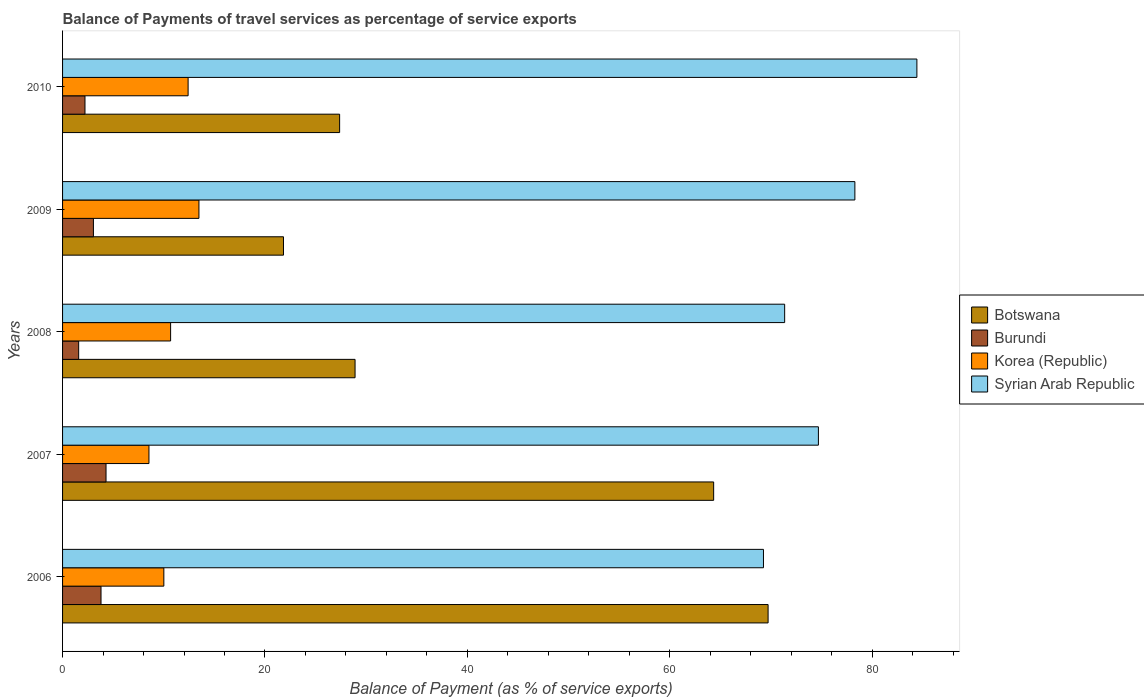How many different coloured bars are there?
Make the answer very short. 4. How many bars are there on the 3rd tick from the top?
Give a very brief answer. 4. What is the label of the 3rd group of bars from the top?
Keep it short and to the point. 2008. What is the balance of payments of travel services in Syrian Arab Republic in 2006?
Provide a succinct answer. 69.25. Across all years, what is the maximum balance of payments of travel services in Burundi?
Your answer should be compact. 4.29. Across all years, what is the minimum balance of payments of travel services in Burundi?
Keep it short and to the point. 1.59. In which year was the balance of payments of travel services in Botswana maximum?
Your answer should be compact. 2006. What is the total balance of payments of travel services in Syrian Arab Republic in the graph?
Offer a terse response. 377.99. What is the difference between the balance of payments of travel services in Botswana in 2006 and that in 2010?
Provide a short and direct response. 42.34. What is the difference between the balance of payments of travel services in Syrian Arab Republic in 2010 and the balance of payments of travel services in Korea (Republic) in 2006?
Your answer should be very brief. 74.41. What is the average balance of payments of travel services in Syrian Arab Republic per year?
Provide a succinct answer. 75.6. In the year 2006, what is the difference between the balance of payments of travel services in Syrian Arab Republic and balance of payments of travel services in Korea (Republic)?
Give a very brief answer. 59.25. What is the ratio of the balance of payments of travel services in Botswana in 2007 to that in 2008?
Give a very brief answer. 2.23. Is the difference between the balance of payments of travel services in Syrian Arab Republic in 2006 and 2010 greater than the difference between the balance of payments of travel services in Korea (Republic) in 2006 and 2010?
Offer a terse response. No. What is the difference between the highest and the second highest balance of payments of travel services in Syrian Arab Republic?
Keep it short and to the point. 6.13. What is the difference between the highest and the lowest balance of payments of travel services in Syrian Arab Republic?
Your response must be concise. 15.16. What does the 1st bar from the top in 2010 represents?
Make the answer very short. Syrian Arab Republic. What does the 1st bar from the bottom in 2006 represents?
Your answer should be compact. Botswana. Is it the case that in every year, the sum of the balance of payments of travel services in Botswana and balance of payments of travel services in Korea (Republic) is greater than the balance of payments of travel services in Syrian Arab Republic?
Your response must be concise. No. How many bars are there?
Provide a succinct answer. 20. Are all the bars in the graph horizontal?
Offer a terse response. Yes. What is the difference between two consecutive major ticks on the X-axis?
Give a very brief answer. 20. Does the graph contain any zero values?
Give a very brief answer. No. Does the graph contain grids?
Keep it short and to the point. No. What is the title of the graph?
Ensure brevity in your answer.  Balance of Payments of travel services as percentage of service exports. Does "Angola" appear as one of the legend labels in the graph?
Provide a succinct answer. No. What is the label or title of the X-axis?
Your response must be concise. Balance of Payment (as % of service exports). What is the label or title of the Y-axis?
Your answer should be compact. Years. What is the Balance of Payment (as % of service exports) of Botswana in 2006?
Ensure brevity in your answer.  69.71. What is the Balance of Payment (as % of service exports) of Burundi in 2006?
Your answer should be compact. 3.8. What is the Balance of Payment (as % of service exports) in Korea (Republic) in 2006?
Provide a short and direct response. 10.01. What is the Balance of Payment (as % of service exports) of Syrian Arab Republic in 2006?
Your answer should be very brief. 69.25. What is the Balance of Payment (as % of service exports) in Botswana in 2007?
Offer a very short reply. 64.33. What is the Balance of Payment (as % of service exports) of Burundi in 2007?
Provide a succinct answer. 4.29. What is the Balance of Payment (as % of service exports) of Korea (Republic) in 2007?
Your answer should be very brief. 8.54. What is the Balance of Payment (as % of service exports) of Syrian Arab Republic in 2007?
Keep it short and to the point. 74.68. What is the Balance of Payment (as % of service exports) of Botswana in 2008?
Make the answer very short. 28.9. What is the Balance of Payment (as % of service exports) in Burundi in 2008?
Provide a short and direct response. 1.59. What is the Balance of Payment (as % of service exports) in Korea (Republic) in 2008?
Make the answer very short. 10.68. What is the Balance of Payment (as % of service exports) in Syrian Arab Republic in 2008?
Provide a succinct answer. 71.35. What is the Balance of Payment (as % of service exports) in Botswana in 2009?
Offer a very short reply. 21.83. What is the Balance of Payment (as % of service exports) of Burundi in 2009?
Offer a very short reply. 3.05. What is the Balance of Payment (as % of service exports) of Korea (Republic) in 2009?
Keep it short and to the point. 13.48. What is the Balance of Payment (as % of service exports) in Syrian Arab Republic in 2009?
Ensure brevity in your answer.  78.29. What is the Balance of Payment (as % of service exports) in Botswana in 2010?
Provide a succinct answer. 27.38. What is the Balance of Payment (as % of service exports) of Burundi in 2010?
Keep it short and to the point. 2.21. What is the Balance of Payment (as % of service exports) in Korea (Republic) in 2010?
Provide a short and direct response. 12.4. What is the Balance of Payment (as % of service exports) of Syrian Arab Republic in 2010?
Make the answer very short. 84.41. Across all years, what is the maximum Balance of Payment (as % of service exports) of Botswana?
Make the answer very short. 69.71. Across all years, what is the maximum Balance of Payment (as % of service exports) of Burundi?
Make the answer very short. 4.29. Across all years, what is the maximum Balance of Payment (as % of service exports) of Korea (Republic)?
Keep it short and to the point. 13.48. Across all years, what is the maximum Balance of Payment (as % of service exports) in Syrian Arab Republic?
Offer a terse response. 84.41. Across all years, what is the minimum Balance of Payment (as % of service exports) in Botswana?
Give a very brief answer. 21.83. Across all years, what is the minimum Balance of Payment (as % of service exports) of Burundi?
Provide a short and direct response. 1.59. Across all years, what is the minimum Balance of Payment (as % of service exports) in Korea (Republic)?
Provide a succinct answer. 8.54. Across all years, what is the minimum Balance of Payment (as % of service exports) in Syrian Arab Republic?
Provide a succinct answer. 69.25. What is the total Balance of Payment (as % of service exports) of Botswana in the graph?
Offer a very short reply. 212.15. What is the total Balance of Payment (as % of service exports) in Burundi in the graph?
Your answer should be very brief. 14.95. What is the total Balance of Payment (as % of service exports) of Korea (Republic) in the graph?
Make the answer very short. 55.1. What is the total Balance of Payment (as % of service exports) in Syrian Arab Republic in the graph?
Give a very brief answer. 377.99. What is the difference between the Balance of Payment (as % of service exports) in Botswana in 2006 and that in 2007?
Your answer should be compact. 5.38. What is the difference between the Balance of Payment (as % of service exports) of Burundi in 2006 and that in 2007?
Provide a short and direct response. -0.49. What is the difference between the Balance of Payment (as % of service exports) in Korea (Republic) in 2006 and that in 2007?
Offer a terse response. 1.47. What is the difference between the Balance of Payment (as % of service exports) of Syrian Arab Republic in 2006 and that in 2007?
Your answer should be very brief. -5.43. What is the difference between the Balance of Payment (as % of service exports) in Botswana in 2006 and that in 2008?
Offer a very short reply. 40.81. What is the difference between the Balance of Payment (as % of service exports) of Burundi in 2006 and that in 2008?
Make the answer very short. 2.21. What is the difference between the Balance of Payment (as % of service exports) in Korea (Republic) in 2006 and that in 2008?
Offer a very short reply. -0.67. What is the difference between the Balance of Payment (as % of service exports) of Syrian Arab Republic in 2006 and that in 2008?
Provide a succinct answer. -2.09. What is the difference between the Balance of Payment (as % of service exports) in Botswana in 2006 and that in 2009?
Your answer should be very brief. 47.88. What is the difference between the Balance of Payment (as % of service exports) in Burundi in 2006 and that in 2009?
Provide a succinct answer. 0.75. What is the difference between the Balance of Payment (as % of service exports) in Korea (Republic) in 2006 and that in 2009?
Ensure brevity in your answer.  -3.47. What is the difference between the Balance of Payment (as % of service exports) in Syrian Arab Republic in 2006 and that in 2009?
Make the answer very short. -9.03. What is the difference between the Balance of Payment (as % of service exports) of Botswana in 2006 and that in 2010?
Ensure brevity in your answer.  42.34. What is the difference between the Balance of Payment (as % of service exports) of Burundi in 2006 and that in 2010?
Provide a short and direct response. 1.59. What is the difference between the Balance of Payment (as % of service exports) in Korea (Republic) in 2006 and that in 2010?
Ensure brevity in your answer.  -2.4. What is the difference between the Balance of Payment (as % of service exports) of Syrian Arab Republic in 2006 and that in 2010?
Provide a succinct answer. -15.16. What is the difference between the Balance of Payment (as % of service exports) of Botswana in 2007 and that in 2008?
Make the answer very short. 35.43. What is the difference between the Balance of Payment (as % of service exports) in Burundi in 2007 and that in 2008?
Your answer should be compact. 2.7. What is the difference between the Balance of Payment (as % of service exports) of Korea (Republic) in 2007 and that in 2008?
Give a very brief answer. -2.14. What is the difference between the Balance of Payment (as % of service exports) of Syrian Arab Republic in 2007 and that in 2008?
Ensure brevity in your answer.  3.33. What is the difference between the Balance of Payment (as % of service exports) in Botswana in 2007 and that in 2009?
Ensure brevity in your answer.  42.5. What is the difference between the Balance of Payment (as % of service exports) in Burundi in 2007 and that in 2009?
Make the answer very short. 1.25. What is the difference between the Balance of Payment (as % of service exports) in Korea (Republic) in 2007 and that in 2009?
Provide a succinct answer. -4.94. What is the difference between the Balance of Payment (as % of service exports) in Syrian Arab Republic in 2007 and that in 2009?
Your response must be concise. -3.6. What is the difference between the Balance of Payment (as % of service exports) in Botswana in 2007 and that in 2010?
Your answer should be very brief. 36.96. What is the difference between the Balance of Payment (as % of service exports) of Burundi in 2007 and that in 2010?
Ensure brevity in your answer.  2.08. What is the difference between the Balance of Payment (as % of service exports) in Korea (Republic) in 2007 and that in 2010?
Give a very brief answer. -3.87. What is the difference between the Balance of Payment (as % of service exports) of Syrian Arab Republic in 2007 and that in 2010?
Provide a short and direct response. -9.73. What is the difference between the Balance of Payment (as % of service exports) of Botswana in 2008 and that in 2009?
Ensure brevity in your answer.  7.07. What is the difference between the Balance of Payment (as % of service exports) of Burundi in 2008 and that in 2009?
Provide a succinct answer. -1.46. What is the difference between the Balance of Payment (as % of service exports) in Korea (Republic) in 2008 and that in 2009?
Your answer should be very brief. -2.8. What is the difference between the Balance of Payment (as % of service exports) in Syrian Arab Republic in 2008 and that in 2009?
Make the answer very short. -6.94. What is the difference between the Balance of Payment (as % of service exports) of Botswana in 2008 and that in 2010?
Offer a very short reply. 1.53. What is the difference between the Balance of Payment (as % of service exports) in Burundi in 2008 and that in 2010?
Provide a succinct answer. -0.62. What is the difference between the Balance of Payment (as % of service exports) of Korea (Republic) in 2008 and that in 2010?
Your answer should be very brief. -1.73. What is the difference between the Balance of Payment (as % of service exports) in Syrian Arab Republic in 2008 and that in 2010?
Provide a succinct answer. -13.07. What is the difference between the Balance of Payment (as % of service exports) of Botswana in 2009 and that in 2010?
Your response must be concise. -5.55. What is the difference between the Balance of Payment (as % of service exports) of Burundi in 2009 and that in 2010?
Your answer should be compact. 0.83. What is the difference between the Balance of Payment (as % of service exports) of Korea (Republic) in 2009 and that in 2010?
Give a very brief answer. 1.07. What is the difference between the Balance of Payment (as % of service exports) of Syrian Arab Republic in 2009 and that in 2010?
Your answer should be very brief. -6.13. What is the difference between the Balance of Payment (as % of service exports) in Botswana in 2006 and the Balance of Payment (as % of service exports) in Burundi in 2007?
Provide a succinct answer. 65.42. What is the difference between the Balance of Payment (as % of service exports) of Botswana in 2006 and the Balance of Payment (as % of service exports) of Korea (Republic) in 2007?
Your response must be concise. 61.18. What is the difference between the Balance of Payment (as % of service exports) of Botswana in 2006 and the Balance of Payment (as % of service exports) of Syrian Arab Republic in 2007?
Keep it short and to the point. -4.97. What is the difference between the Balance of Payment (as % of service exports) of Burundi in 2006 and the Balance of Payment (as % of service exports) of Korea (Republic) in 2007?
Ensure brevity in your answer.  -4.74. What is the difference between the Balance of Payment (as % of service exports) of Burundi in 2006 and the Balance of Payment (as % of service exports) of Syrian Arab Republic in 2007?
Ensure brevity in your answer.  -70.88. What is the difference between the Balance of Payment (as % of service exports) of Korea (Republic) in 2006 and the Balance of Payment (as % of service exports) of Syrian Arab Republic in 2007?
Provide a succinct answer. -64.68. What is the difference between the Balance of Payment (as % of service exports) in Botswana in 2006 and the Balance of Payment (as % of service exports) in Burundi in 2008?
Give a very brief answer. 68.12. What is the difference between the Balance of Payment (as % of service exports) in Botswana in 2006 and the Balance of Payment (as % of service exports) in Korea (Republic) in 2008?
Offer a very short reply. 59.04. What is the difference between the Balance of Payment (as % of service exports) in Botswana in 2006 and the Balance of Payment (as % of service exports) in Syrian Arab Republic in 2008?
Make the answer very short. -1.64. What is the difference between the Balance of Payment (as % of service exports) of Burundi in 2006 and the Balance of Payment (as % of service exports) of Korea (Republic) in 2008?
Your answer should be very brief. -6.88. What is the difference between the Balance of Payment (as % of service exports) in Burundi in 2006 and the Balance of Payment (as % of service exports) in Syrian Arab Republic in 2008?
Provide a succinct answer. -67.55. What is the difference between the Balance of Payment (as % of service exports) in Korea (Republic) in 2006 and the Balance of Payment (as % of service exports) in Syrian Arab Republic in 2008?
Your answer should be very brief. -61.34. What is the difference between the Balance of Payment (as % of service exports) of Botswana in 2006 and the Balance of Payment (as % of service exports) of Burundi in 2009?
Give a very brief answer. 66.66. What is the difference between the Balance of Payment (as % of service exports) in Botswana in 2006 and the Balance of Payment (as % of service exports) in Korea (Republic) in 2009?
Offer a terse response. 56.24. What is the difference between the Balance of Payment (as % of service exports) of Botswana in 2006 and the Balance of Payment (as % of service exports) of Syrian Arab Republic in 2009?
Your answer should be very brief. -8.57. What is the difference between the Balance of Payment (as % of service exports) in Burundi in 2006 and the Balance of Payment (as % of service exports) in Korea (Republic) in 2009?
Provide a short and direct response. -9.68. What is the difference between the Balance of Payment (as % of service exports) of Burundi in 2006 and the Balance of Payment (as % of service exports) of Syrian Arab Republic in 2009?
Make the answer very short. -74.49. What is the difference between the Balance of Payment (as % of service exports) of Korea (Republic) in 2006 and the Balance of Payment (as % of service exports) of Syrian Arab Republic in 2009?
Ensure brevity in your answer.  -68.28. What is the difference between the Balance of Payment (as % of service exports) in Botswana in 2006 and the Balance of Payment (as % of service exports) in Burundi in 2010?
Offer a terse response. 67.5. What is the difference between the Balance of Payment (as % of service exports) of Botswana in 2006 and the Balance of Payment (as % of service exports) of Korea (Republic) in 2010?
Make the answer very short. 57.31. What is the difference between the Balance of Payment (as % of service exports) of Botswana in 2006 and the Balance of Payment (as % of service exports) of Syrian Arab Republic in 2010?
Make the answer very short. -14.7. What is the difference between the Balance of Payment (as % of service exports) in Burundi in 2006 and the Balance of Payment (as % of service exports) in Korea (Republic) in 2010?
Make the answer very short. -8.6. What is the difference between the Balance of Payment (as % of service exports) of Burundi in 2006 and the Balance of Payment (as % of service exports) of Syrian Arab Republic in 2010?
Ensure brevity in your answer.  -80.61. What is the difference between the Balance of Payment (as % of service exports) in Korea (Republic) in 2006 and the Balance of Payment (as % of service exports) in Syrian Arab Republic in 2010?
Provide a short and direct response. -74.41. What is the difference between the Balance of Payment (as % of service exports) of Botswana in 2007 and the Balance of Payment (as % of service exports) of Burundi in 2008?
Your response must be concise. 62.74. What is the difference between the Balance of Payment (as % of service exports) in Botswana in 2007 and the Balance of Payment (as % of service exports) in Korea (Republic) in 2008?
Offer a terse response. 53.66. What is the difference between the Balance of Payment (as % of service exports) in Botswana in 2007 and the Balance of Payment (as % of service exports) in Syrian Arab Republic in 2008?
Keep it short and to the point. -7.01. What is the difference between the Balance of Payment (as % of service exports) of Burundi in 2007 and the Balance of Payment (as % of service exports) of Korea (Republic) in 2008?
Provide a short and direct response. -6.38. What is the difference between the Balance of Payment (as % of service exports) of Burundi in 2007 and the Balance of Payment (as % of service exports) of Syrian Arab Republic in 2008?
Provide a short and direct response. -67.05. What is the difference between the Balance of Payment (as % of service exports) in Korea (Republic) in 2007 and the Balance of Payment (as % of service exports) in Syrian Arab Republic in 2008?
Make the answer very short. -62.81. What is the difference between the Balance of Payment (as % of service exports) of Botswana in 2007 and the Balance of Payment (as % of service exports) of Burundi in 2009?
Your answer should be compact. 61.28. What is the difference between the Balance of Payment (as % of service exports) of Botswana in 2007 and the Balance of Payment (as % of service exports) of Korea (Republic) in 2009?
Keep it short and to the point. 50.86. What is the difference between the Balance of Payment (as % of service exports) of Botswana in 2007 and the Balance of Payment (as % of service exports) of Syrian Arab Republic in 2009?
Provide a short and direct response. -13.95. What is the difference between the Balance of Payment (as % of service exports) of Burundi in 2007 and the Balance of Payment (as % of service exports) of Korea (Republic) in 2009?
Ensure brevity in your answer.  -9.18. What is the difference between the Balance of Payment (as % of service exports) of Burundi in 2007 and the Balance of Payment (as % of service exports) of Syrian Arab Republic in 2009?
Provide a succinct answer. -73.99. What is the difference between the Balance of Payment (as % of service exports) of Korea (Republic) in 2007 and the Balance of Payment (as % of service exports) of Syrian Arab Republic in 2009?
Your answer should be compact. -69.75. What is the difference between the Balance of Payment (as % of service exports) of Botswana in 2007 and the Balance of Payment (as % of service exports) of Burundi in 2010?
Offer a terse response. 62.12. What is the difference between the Balance of Payment (as % of service exports) in Botswana in 2007 and the Balance of Payment (as % of service exports) in Korea (Republic) in 2010?
Offer a terse response. 51.93. What is the difference between the Balance of Payment (as % of service exports) in Botswana in 2007 and the Balance of Payment (as % of service exports) in Syrian Arab Republic in 2010?
Your response must be concise. -20.08. What is the difference between the Balance of Payment (as % of service exports) of Burundi in 2007 and the Balance of Payment (as % of service exports) of Korea (Republic) in 2010?
Your response must be concise. -8.11. What is the difference between the Balance of Payment (as % of service exports) of Burundi in 2007 and the Balance of Payment (as % of service exports) of Syrian Arab Republic in 2010?
Ensure brevity in your answer.  -80.12. What is the difference between the Balance of Payment (as % of service exports) in Korea (Republic) in 2007 and the Balance of Payment (as % of service exports) in Syrian Arab Republic in 2010?
Keep it short and to the point. -75.88. What is the difference between the Balance of Payment (as % of service exports) of Botswana in 2008 and the Balance of Payment (as % of service exports) of Burundi in 2009?
Give a very brief answer. 25.85. What is the difference between the Balance of Payment (as % of service exports) in Botswana in 2008 and the Balance of Payment (as % of service exports) in Korea (Republic) in 2009?
Provide a short and direct response. 15.43. What is the difference between the Balance of Payment (as % of service exports) in Botswana in 2008 and the Balance of Payment (as % of service exports) in Syrian Arab Republic in 2009?
Provide a short and direct response. -49.39. What is the difference between the Balance of Payment (as % of service exports) in Burundi in 2008 and the Balance of Payment (as % of service exports) in Korea (Republic) in 2009?
Keep it short and to the point. -11.88. What is the difference between the Balance of Payment (as % of service exports) of Burundi in 2008 and the Balance of Payment (as % of service exports) of Syrian Arab Republic in 2009?
Make the answer very short. -76.7. What is the difference between the Balance of Payment (as % of service exports) of Korea (Republic) in 2008 and the Balance of Payment (as % of service exports) of Syrian Arab Republic in 2009?
Provide a succinct answer. -67.61. What is the difference between the Balance of Payment (as % of service exports) in Botswana in 2008 and the Balance of Payment (as % of service exports) in Burundi in 2010?
Ensure brevity in your answer.  26.69. What is the difference between the Balance of Payment (as % of service exports) of Botswana in 2008 and the Balance of Payment (as % of service exports) of Korea (Republic) in 2010?
Offer a very short reply. 16.5. What is the difference between the Balance of Payment (as % of service exports) in Botswana in 2008 and the Balance of Payment (as % of service exports) in Syrian Arab Republic in 2010?
Your response must be concise. -55.51. What is the difference between the Balance of Payment (as % of service exports) in Burundi in 2008 and the Balance of Payment (as % of service exports) in Korea (Republic) in 2010?
Provide a short and direct response. -10.81. What is the difference between the Balance of Payment (as % of service exports) in Burundi in 2008 and the Balance of Payment (as % of service exports) in Syrian Arab Republic in 2010?
Give a very brief answer. -82.82. What is the difference between the Balance of Payment (as % of service exports) in Korea (Republic) in 2008 and the Balance of Payment (as % of service exports) in Syrian Arab Republic in 2010?
Make the answer very short. -73.74. What is the difference between the Balance of Payment (as % of service exports) in Botswana in 2009 and the Balance of Payment (as % of service exports) in Burundi in 2010?
Give a very brief answer. 19.61. What is the difference between the Balance of Payment (as % of service exports) of Botswana in 2009 and the Balance of Payment (as % of service exports) of Korea (Republic) in 2010?
Give a very brief answer. 9.42. What is the difference between the Balance of Payment (as % of service exports) in Botswana in 2009 and the Balance of Payment (as % of service exports) in Syrian Arab Republic in 2010?
Ensure brevity in your answer.  -62.58. What is the difference between the Balance of Payment (as % of service exports) in Burundi in 2009 and the Balance of Payment (as % of service exports) in Korea (Republic) in 2010?
Your answer should be very brief. -9.36. What is the difference between the Balance of Payment (as % of service exports) of Burundi in 2009 and the Balance of Payment (as % of service exports) of Syrian Arab Republic in 2010?
Give a very brief answer. -81.36. What is the difference between the Balance of Payment (as % of service exports) of Korea (Republic) in 2009 and the Balance of Payment (as % of service exports) of Syrian Arab Republic in 2010?
Keep it short and to the point. -70.94. What is the average Balance of Payment (as % of service exports) of Botswana per year?
Offer a terse response. 42.43. What is the average Balance of Payment (as % of service exports) in Burundi per year?
Keep it short and to the point. 2.99. What is the average Balance of Payment (as % of service exports) of Korea (Republic) per year?
Your answer should be very brief. 11.02. What is the average Balance of Payment (as % of service exports) of Syrian Arab Republic per year?
Offer a terse response. 75.6. In the year 2006, what is the difference between the Balance of Payment (as % of service exports) in Botswana and Balance of Payment (as % of service exports) in Burundi?
Offer a very short reply. 65.91. In the year 2006, what is the difference between the Balance of Payment (as % of service exports) in Botswana and Balance of Payment (as % of service exports) in Korea (Republic)?
Provide a succinct answer. 59.71. In the year 2006, what is the difference between the Balance of Payment (as % of service exports) of Botswana and Balance of Payment (as % of service exports) of Syrian Arab Republic?
Make the answer very short. 0.46. In the year 2006, what is the difference between the Balance of Payment (as % of service exports) of Burundi and Balance of Payment (as % of service exports) of Korea (Republic)?
Ensure brevity in your answer.  -6.21. In the year 2006, what is the difference between the Balance of Payment (as % of service exports) of Burundi and Balance of Payment (as % of service exports) of Syrian Arab Republic?
Give a very brief answer. -65.45. In the year 2006, what is the difference between the Balance of Payment (as % of service exports) of Korea (Republic) and Balance of Payment (as % of service exports) of Syrian Arab Republic?
Provide a short and direct response. -59.25. In the year 2007, what is the difference between the Balance of Payment (as % of service exports) in Botswana and Balance of Payment (as % of service exports) in Burundi?
Make the answer very short. 60.04. In the year 2007, what is the difference between the Balance of Payment (as % of service exports) in Botswana and Balance of Payment (as % of service exports) in Korea (Republic)?
Your response must be concise. 55.8. In the year 2007, what is the difference between the Balance of Payment (as % of service exports) in Botswana and Balance of Payment (as % of service exports) in Syrian Arab Republic?
Provide a short and direct response. -10.35. In the year 2007, what is the difference between the Balance of Payment (as % of service exports) in Burundi and Balance of Payment (as % of service exports) in Korea (Republic)?
Offer a terse response. -4.24. In the year 2007, what is the difference between the Balance of Payment (as % of service exports) in Burundi and Balance of Payment (as % of service exports) in Syrian Arab Republic?
Give a very brief answer. -70.39. In the year 2007, what is the difference between the Balance of Payment (as % of service exports) in Korea (Republic) and Balance of Payment (as % of service exports) in Syrian Arab Republic?
Your answer should be compact. -66.15. In the year 2008, what is the difference between the Balance of Payment (as % of service exports) of Botswana and Balance of Payment (as % of service exports) of Burundi?
Ensure brevity in your answer.  27.31. In the year 2008, what is the difference between the Balance of Payment (as % of service exports) in Botswana and Balance of Payment (as % of service exports) in Korea (Republic)?
Give a very brief answer. 18.23. In the year 2008, what is the difference between the Balance of Payment (as % of service exports) in Botswana and Balance of Payment (as % of service exports) in Syrian Arab Republic?
Give a very brief answer. -42.45. In the year 2008, what is the difference between the Balance of Payment (as % of service exports) in Burundi and Balance of Payment (as % of service exports) in Korea (Republic)?
Offer a very short reply. -9.08. In the year 2008, what is the difference between the Balance of Payment (as % of service exports) of Burundi and Balance of Payment (as % of service exports) of Syrian Arab Republic?
Make the answer very short. -69.76. In the year 2008, what is the difference between the Balance of Payment (as % of service exports) of Korea (Republic) and Balance of Payment (as % of service exports) of Syrian Arab Republic?
Your answer should be very brief. -60.67. In the year 2009, what is the difference between the Balance of Payment (as % of service exports) of Botswana and Balance of Payment (as % of service exports) of Burundi?
Your answer should be compact. 18.78. In the year 2009, what is the difference between the Balance of Payment (as % of service exports) in Botswana and Balance of Payment (as % of service exports) in Korea (Republic)?
Make the answer very short. 8.35. In the year 2009, what is the difference between the Balance of Payment (as % of service exports) of Botswana and Balance of Payment (as % of service exports) of Syrian Arab Republic?
Give a very brief answer. -56.46. In the year 2009, what is the difference between the Balance of Payment (as % of service exports) in Burundi and Balance of Payment (as % of service exports) in Korea (Republic)?
Your answer should be very brief. -10.43. In the year 2009, what is the difference between the Balance of Payment (as % of service exports) of Burundi and Balance of Payment (as % of service exports) of Syrian Arab Republic?
Your answer should be compact. -75.24. In the year 2009, what is the difference between the Balance of Payment (as % of service exports) of Korea (Republic) and Balance of Payment (as % of service exports) of Syrian Arab Republic?
Your answer should be compact. -64.81. In the year 2010, what is the difference between the Balance of Payment (as % of service exports) of Botswana and Balance of Payment (as % of service exports) of Burundi?
Provide a short and direct response. 25.16. In the year 2010, what is the difference between the Balance of Payment (as % of service exports) of Botswana and Balance of Payment (as % of service exports) of Korea (Republic)?
Offer a terse response. 14.97. In the year 2010, what is the difference between the Balance of Payment (as % of service exports) of Botswana and Balance of Payment (as % of service exports) of Syrian Arab Republic?
Your answer should be very brief. -57.04. In the year 2010, what is the difference between the Balance of Payment (as % of service exports) of Burundi and Balance of Payment (as % of service exports) of Korea (Republic)?
Your response must be concise. -10.19. In the year 2010, what is the difference between the Balance of Payment (as % of service exports) of Burundi and Balance of Payment (as % of service exports) of Syrian Arab Republic?
Your answer should be compact. -82.2. In the year 2010, what is the difference between the Balance of Payment (as % of service exports) of Korea (Republic) and Balance of Payment (as % of service exports) of Syrian Arab Republic?
Your response must be concise. -72.01. What is the ratio of the Balance of Payment (as % of service exports) in Botswana in 2006 to that in 2007?
Make the answer very short. 1.08. What is the ratio of the Balance of Payment (as % of service exports) in Burundi in 2006 to that in 2007?
Provide a short and direct response. 0.88. What is the ratio of the Balance of Payment (as % of service exports) of Korea (Republic) in 2006 to that in 2007?
Make the answer very short. 1.17. What is the ratio of the Balance of Payment (as % of service exports) of Syrian Arab Republic in 2006 to that in 2007?
Ensure brevity in your answer.  0.93. What is the ratio of the Balance of Payment (as % of service exports) of Botswana in 2006 to that in 2008?
Keep it short and to the point. 2.41. What is the ratio of the Balance of Payment (as % of service exports) in Burundi in 2006 to that in 2008?
Provide a short and direct response. 2.39. What is the ratio of the Balance of Payment (as % of service exports) in Korea (Republic) in 2006 to that in 2008?
Provide a short and direct response. 0.94. What is the ratio of the Balance of Payment (as % of service exports) of Syrian Arab Republic in 2006 to that in 2008?
Provide a short and direct response. 0.97. What is the ratio of the Balance of Payment (as % of service exports) in Botswana in 2006 to that in 2009?
Your response must be concise. 3.19. What is the ratio of the Balance of Payment (as % of service exports) of Burundi in 2006 to that in 2009?
Your answer should be very brief. 1.25. What is the ratio of the Balance of Payment (as % of service exports) in Korea (Republic) in 2006 to that in 2009?
Keep it short and to the point. 0.74. What is the ratio of the Balance of Payment (as % of service exports) of Syrian Arab Republic in 2006 to that in 2009?
Offer a terse response. 0.88. What is the ratio of the Balance of Payment (as % of service exports) of Botswana in 2006 to that in 2010?
Ensure brevity in your answer.  2.55. What is the ratio of the Balance of Payment (as % of service exports) of Burundi in 2006 to that in 2010?
Your response must be concise. 1.72. What is the ratio of the Balance of Payment (as % of service exports) in Korea (Republic) in 2006 to that in 2010?
Ensure brevity in your answer.  0.81. What is the ratio of the Balance of Payment (as % of service exports) in Syrian Arab Republic in 2006 to that in 2010?
Your answer should be compact. 0.82. What is the ratio of the Balance of Payment (as % of service exports) of Botswana in 2007 to that in 2008?
Keep it short and to the point. 2.23. What is the ratio of the Balance of Payment (as % of service exports) of Burundi in 2007 to that in 2008?
Provide a short and direct response. 2.7. What is the ratio of the Balance of Payment (as % of service exports) in Korea (Republic) in 2007 to that in 2008?
Provide a succinct answer. 0.8. What is the ratio of the Balance of Payment (as % of service exports) of Syrian Arab Republic in 2007 to that in 2008?
Your answer should be very brief. 1.05. What is the ratio of the Balance of Payment (as % of service exports) of Botswana in 2007 to that in 2009?
Offer a terse response. 2.95. What is the ratio of the Balance of Payment (as % of service exports) of Burundi in 2007 to that in 2009?
Make the answer very short. 1.41. What is the ratio of the Balance of Payment (as % of service exports) of Korea (Republic) in 2007 to that in 2009?
Provide a succinct answer. 0.63. What is the ratio of the Balance of Payment (as % of service exports) of Syrian Arab Republic in 2007 to that in 2009?
Ensure brevity in your answer.  0.95. What is the ratio of the Balance of Payment (as % of service exports) of Botswana in 2007 to that in 2010?
Give a very brief answer. 2.35. What is the ratio of the Balance of Payment (as % of service exports) of Burundi in 2007 to that in 2010?
Keep it short and to the point. 1.94. What is the ratio of the Balance of Payment (as % of service exports) in Korea (Republic) in 2007 to that in 2010?
Provide a succinct answer. 0.69. What is the ratio of the Balance of Payment (as % of service exports) of Syrian Arab Republic in 2007 to that in 2010?
Your answer should be very brief. 0.88. What is the ratio of the Balance of Payment (as % of service exports) in Botswana in 2008 to that in 2009?
Your answer should be compact. 1.32. What is the ratio of the Balance of Payment (as % of service exports) of Burundi in 2008 to that in 2009?
Offer a terse response. 0.52. What is the ratio of the Balance of Payment (as % of service exports) of Korea (Republic) in 2008 to that in 2009?
Your response must be concise. 0.79. What is the ratio of the Balance of Payment (as % of service exports) of Syrian Arab Republic in 2008 to that in 2009?
Ensure brevity in your answer.  0.91. What is the ratio of the Balance of Payment (as % of service exports) of Botswana in 2008 to that in 2010?
Provide a short and direct response. 1.06. What is the ratio of the Balance of Payment (as % of service exports) of Burundi in 2008 to that in 2010?
Provide a succinct answer. 0.72. What is the ratio of the Balance of Payment (as % of service exports) in Korea (Republic) in 2008 to that in 2010?
Your response must be concise. 0.86. What is the ratio of the Balance of Payment (as % of service exports) in Syrian Arab Republic in 2008 to that in 2010?
Your answer should be very brief. 0.85. What is the ratio of the Balance of Payment (as % of service exports) in Botswana in 2009 to that in 2010?
Make the answer very short. 0.8. What is the ratio of the Balance of Payment (as % of service exports) of Burundi in 2009 to that in 2010?
Make the answer very short. 1.38. What is the ratio of the Balance of Payment (as % of service exports) of Korea (Republic) in 2009 to that in 2010?
Make the answer very short. 1.09. What is the ratio of the Balance of Payment (as % of service exports) of Syrian Arab Republic in 2009 to that in 2010?
Your answer should be very brief. 0.93. What is the difference between the highest and the second highest Balance of Payment (as % of service exports) of Botswana?
Make the answer very short. 5.38. What is the difference between the highest and the second highest Balance of Payment (as % of service exports) of Burundi?
Your answer should be very brief. 0.49. What is the difference between the highest and the second highest Balance of Payment (as % of service exports) in Korea (Republic)?
Your answer should be very brief. 1.07. What is the difference between the highest and the second highest Balance of Payment (as % of service exports) of Syrian Arab Republic?
Provide a short and direct response. 6.13. What is the difference between the highest and the lowest Balance of Payment (as % of service exports) in Botswana?
Provide a succinct answer. 47.88. What is the difference between the highest and the lowest Balance of Payment (as % of service exports) in Burundi?
Provide a succinct answer. 2.7. What is the difference between the highest and the lowest Balance of Payment (as % of service exports) of Korea (Republic)?
Ensure brevity in your answer.  4.94. What is the difference between the highest and the lowest Balance of Payment (as % of service exports) in Syrian Arab Republic?
Provide a succinct answer. 15.16. 